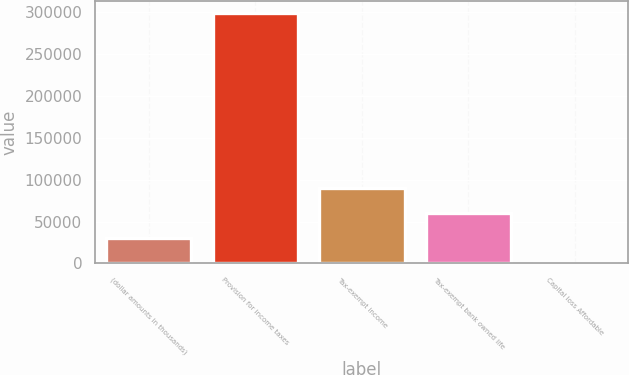Convert chart to OTSL. <chart><loc_0><loc_0><loc_500><loc_500><bar_chart><fcel>(dollar amounts in thousands)<fcel>Provision for income taxes<fcel>Tax-exempt income<fcel>Tax-exempt bank owned life<fcel>Capital loss Affordable<nl><fcel>30774.3<fcel>299094<fcel>90400.9<fcel>60587.6<fcel>961<nl></chart> 